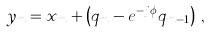Convert formula to latex. <formula><loc_0><loc_0><loc_500><loc_500>y _ { m } = x _ { m } + \left ( q _ { m } - e ^ { - j \phi } q _ { m - 1 } \right ) \, ,</formula> 